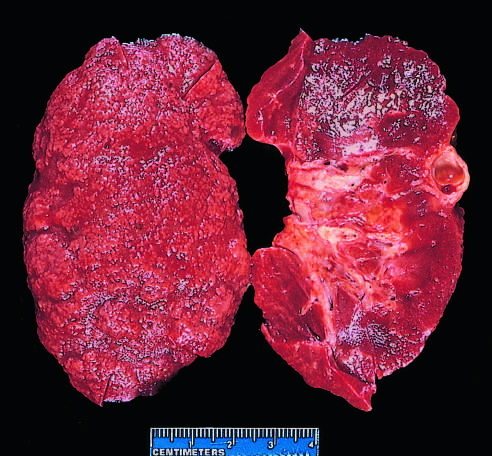what demonstrates diffuse granular transformation of the surface and marked thinning of the cortex (right)?
Answer the question using a single word or phrase. The bisected kidney 